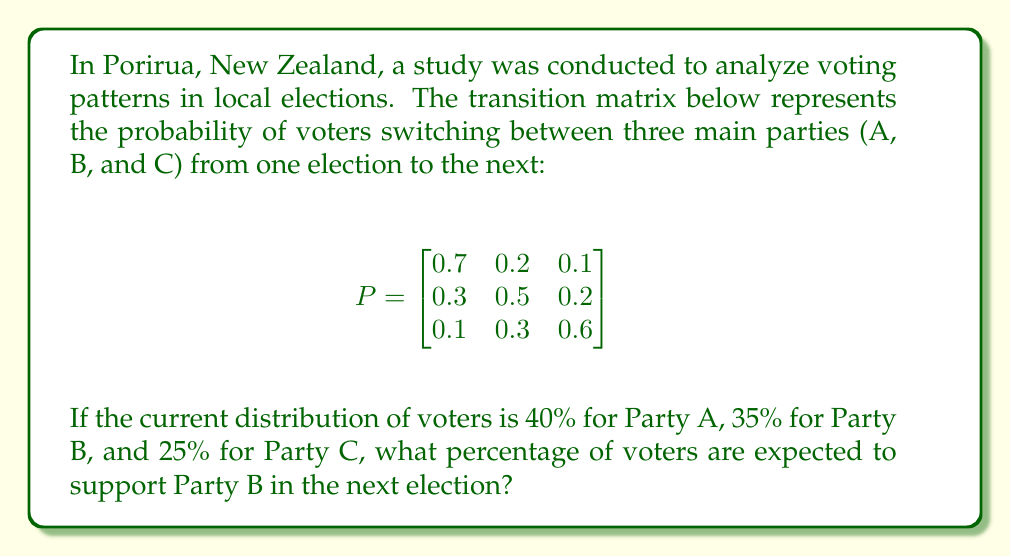Teach me how to tackle this problem. To solve this problem, we need to follow these steps:

1) First, we need to represent the current distribution of voters as a row vector:
   $$v = \begin{bmatrix} 0.4 & 0.35 & 0.25 \end{bmatrix}$$

2) To find the distribution of voters in the next election, we multiply this vector by the transition matrix:
   $$v_{next} = v \cdot P$$

3) Let's perform this matrix multiplication:
   $$\begin{aligned}
   v_{next} &= \begin{bmatrix} 0.4 & 0.35 & 0.25 \end{bmatrix} \cdot 
   \begin{bmatrix}
   0.7 & 0.2 & 0.1 \\
   0.3 & 0.5 & 0.2 \\
   0.1 & 0.3 & 0.6
   \end{bmatrix} \\
   &= \begin{bmatrix}
   (0.4 \cdot 0.7 + 0.35 \cdot 0.3 + 0.25 \cdot 0.1) & 
   (0.4 \cdot 0.2 + 0.35 \cdot 0.5 + 0.25 \cdot 0.3) & 
   (0.4 \cdot 0.1 + 0.35 \cdot 0.2 + 0.25 \cdot 0.6)
   \end{bmatrix} \\
   &= \begin{bmatrix} 0.445 & 0.32 & 0.235 \end{bmatrix}
   \end{aligned}$$

4) The second element of this resulting vector represents the proportion of voters expected to support Party B in the next election.

5) To convert this to a percentage, we multiply by 100:
   $0.32 \cdot 100 = 32\%$

Therefore, 32% of voters are expected to support Party B in the next election.
Answer: 32% 